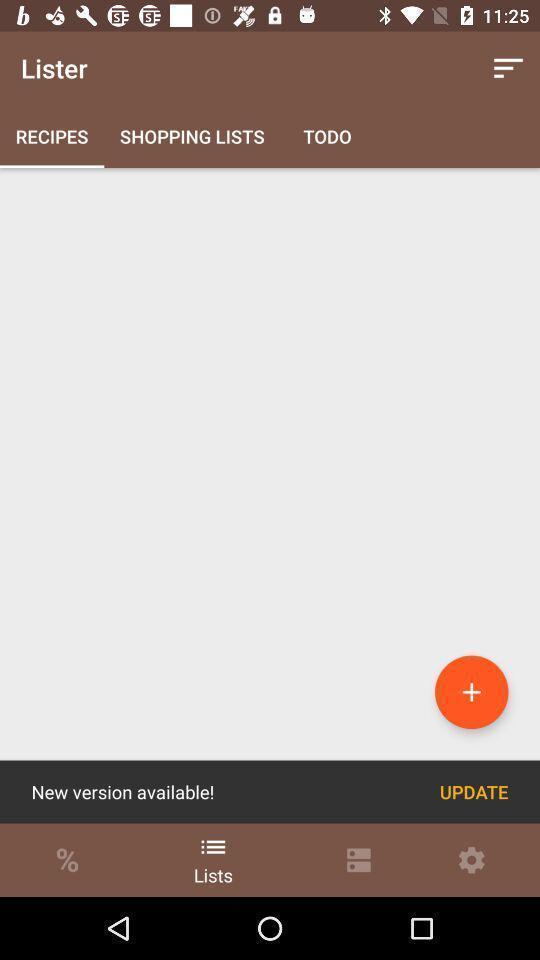Tell me what you see in this picture. Page displays to update new version of app. 